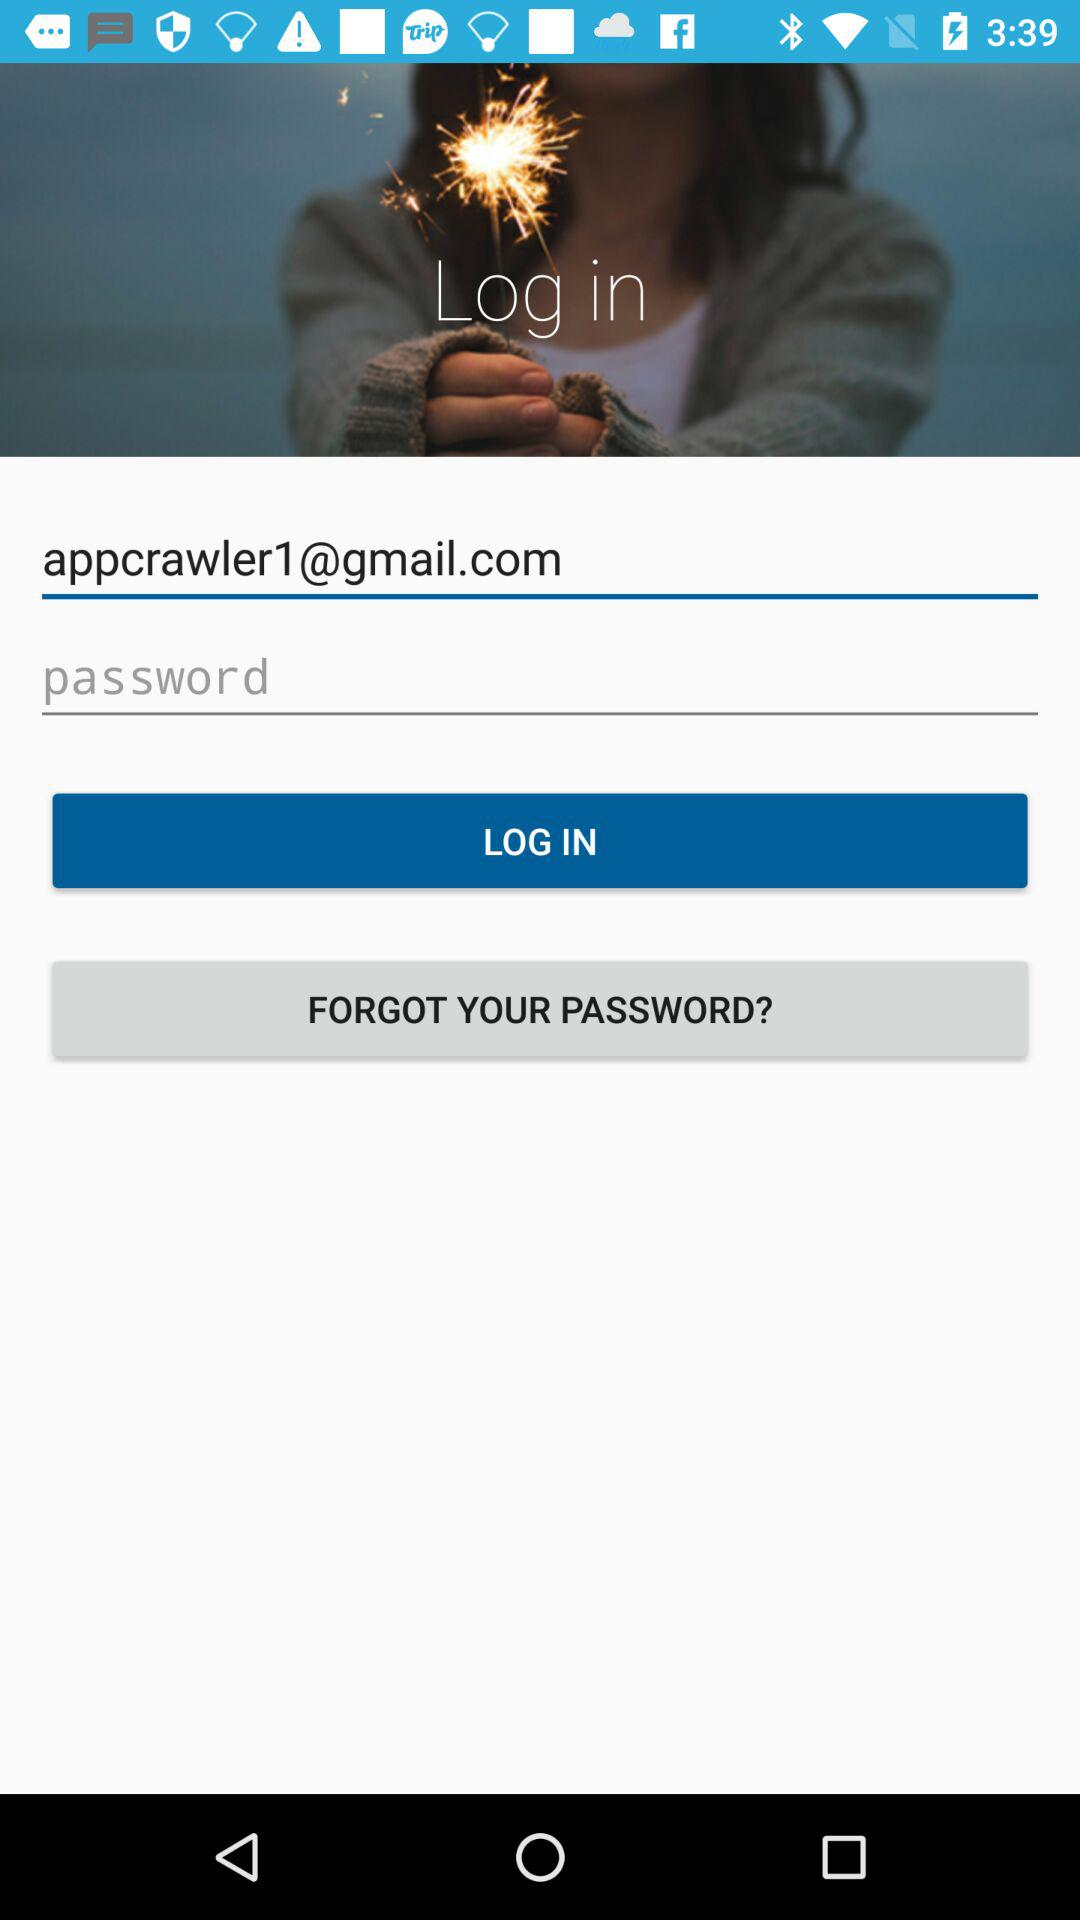What is the email address? The email address is appcrawler1@gmail.com. 